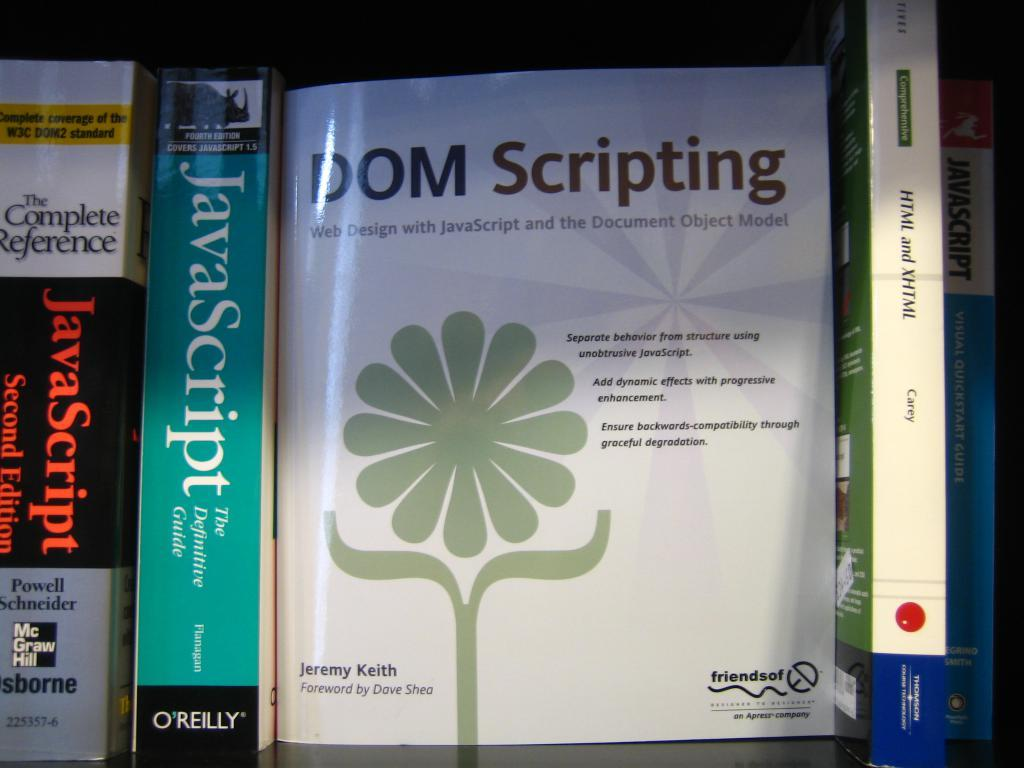Provide a one-sentence caption for the provided image. Front cover of a book called "DOM Scripting". 